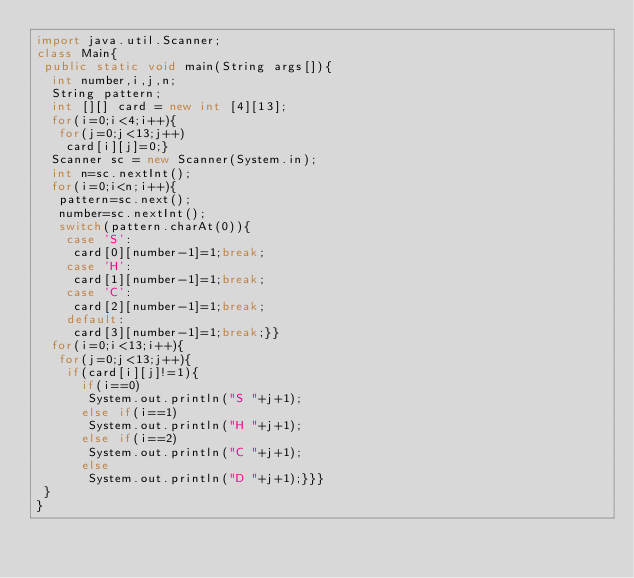<code> <loc_0><loc_0><loc_500><loc_500><_Java_>import java.util.Scanner;
class Main{
 public static void main(String args[]){
  int number,i,j,n;
  String pattern;
  int [][] card = new int [4][13];
  for(i=0;i<4;i++){
   for(j=0;j<13;j++)
    card[i][j]=0;}
  Scanner sc = new Scanner(System.in);
  int n=sc.nextInt();
  for(i=0;i<n;i++){
   pattern=sc.next();
   number=sc.nextInt();
   switch(pattern.charAt(0)){
    case 'S':
     card[0][number-1]=1;break;
    case 'H':
     card[1][number-1]=1;break;
    case 'C':
     card[2][number-1]=1;break;
    default:
     card[3][number-1]=1;break;}}
  for(i=0;i<13;i++){
   for(j=0;j<13;j++){
    if(card[i][j]!=1){
      if(i==0)
       System.out.println("S "+j+1);
      else if(i==1)
       System.out.println("H "+j+1);
      else if(i==2)
       System.out.println("C "+j+1);
      else
       System.out.println("D "+j+1);}}}
 }
}
</code> 